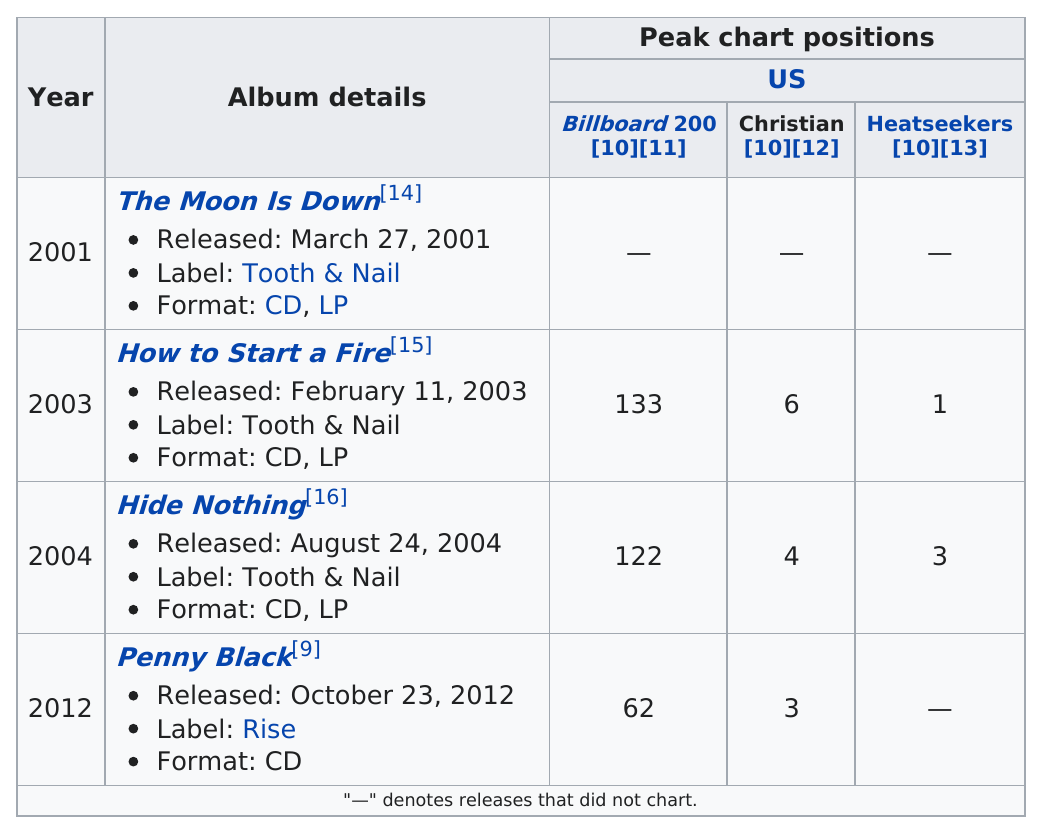Identify some key points in this picture. This band has released 4 albums. The last album recorded by the band Penny Black was released on [date]. Which album is the best performing on the US charts? I believe it is How to Start a Fire... The artist produced 4 albums. 